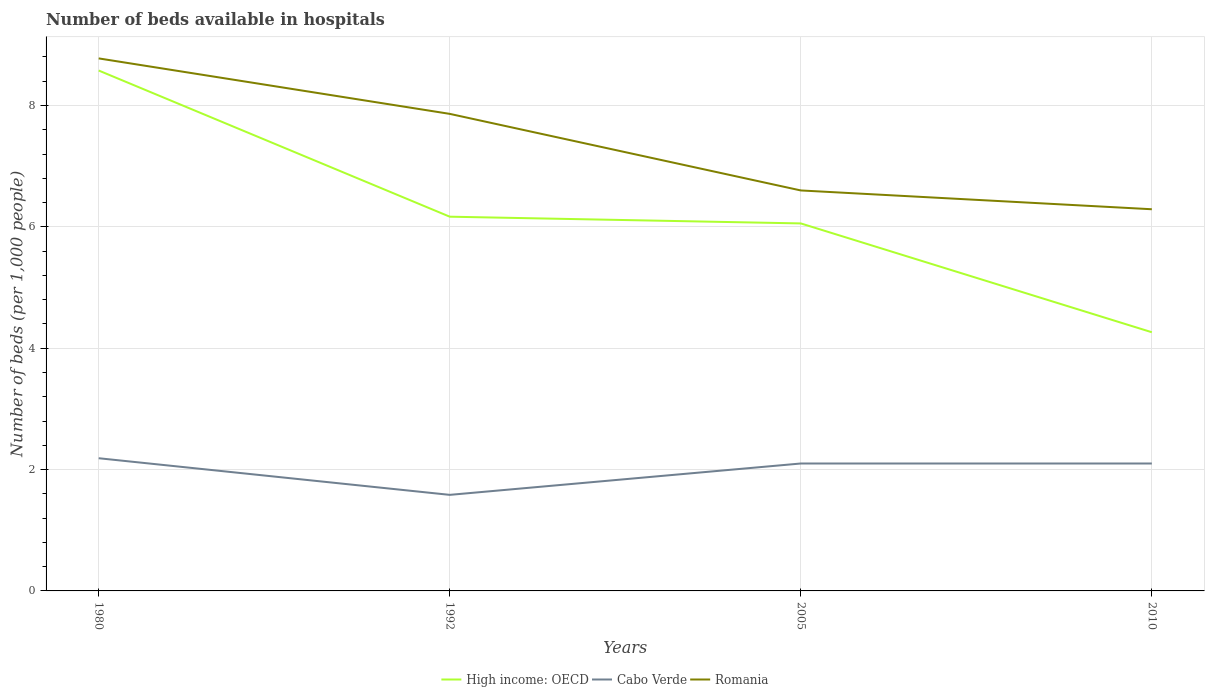How many different coloured lines are there?
Offer a very short reply. 3. Does the line corresponding to Romania intersect with the line corresponding to Cabo Verde?
Your answer should be compact. No. Across all years, what is the maximum number of beds in the hospiatls of in High income: OECD?
Ensure brevity in your answer.  4.26. What is the total number of beds in the hospiatls of in High income: OECD in the graph?
Your answer should be very brief. 1.79. What is the difference between the highest and the second highest number of beds in the hospiatls of in Romania?
Make the answer very short. 2.49. What is the difference between two consecutive major ticks on the Y-axis?
Give a very brief answer. 2. Are the values on the major ticks of Y-axis written in scientific E-notation?
Offer a very short reply. No. Where does the legend appear in the graph?
Ensure brevity in your answer.  Bottom center. How are the legend labels stacked?
Offer a terse response. Horizontal. What is the title of the graph?
Your answer should be very brief. Number of beds available in hospitals. Does "Ecuador" appear as one of the legend labels in the graph?
Provide a succinct answer. No. What is the label or title of the X-axis?
Offer a terse response. Years. What is the label or title of the Y-axis?
Offer a terse response. Number of beds (per 1,0 people). What is the Number of beds (per 1,000 people) in High income: OECD in 1980?
Provide a succinct answer. 8.58. What is the Number of beds (per 1,000 people) of Cabo Verde in 1980?
Keep it short and to the point. 2.19. What is the Number of beds (per 1,000 people) of Romania in 1980?
Keep it short and to the point. 8.78. What is the Number of beds (per 1,000 people) of High income: OECD in 1992?
Give a very brief answer. 6.17. What is the Number of beds (per 1,000 people) in Cabo Verde in 1992?
Provide a succinct answer. 1.58. What is the Number of beds (per 1,000 people) of Romania in 1992?
Ensure brevity in your answer.  7.86. What is the Number of beds (per 1,000 people) in High income: OECD in 2005?
Keep it short and to the point. 6.06. What is the Number of beds (per 1,000 people) in High income: OECD in 2010?
Make the answer very short. 4.26. What is the Number of beds (per 1,000 people) in Romania in 2010?
Offer a terse response. 6.29. Across all years, what is the maximum Number of beds (per 1,000 people) in High income: OECD?
Your answer should be very brief. 8.58. Across all years, what is the maximum Number of beds (per 1,000 people) in Cabo Verde?
Provide a short and direct response. 2.19. Across all years, what is the maximum Number of beds (per 1,000 people) of Romania?
Keep it short and to the point. 8.78. Across all years, what is the minimum Number of beds (per 1,000 people) in High income: OECD?
Give a very brief answer. 4.26. Across all years, what is the minimum Number of beds (per 1,000 people) in Cabo Verde?
Your response must be concise. 1.58. Across all years, what is the minimum Number of beds (per 1,000 people) of Romania?
Ensure brevity in your answer.  6.29. What is the total Number of beds (per 1,000 people) in High income: OECD in the graph?
Make the answer very short. 25.06. What is the total Number of beds (per 1,000 people) of Cabo Verde in the graph?
Provide a succinct answer. 7.97. What is the total Number of beds (per 1,000 people) in Romania in the graph?
Provide a short and direct response. 29.53. What is the difference between the Number of beds (per 1,000 people) in High income: OECD in 1980 and that in 1992?
Make the answer very short. 2.41. What is the difference between the Number of beds (per 1,000 people) in Cabo Verde in 1980 and that in 1992?
Give a very brief answer. 0.6. What is the difference between the Number of beds (per 1,000 people) in Romania in 1980 and that in 1992?
Your answer should be compact. 0.91. What is the difference between the Number of beds (per 1,000 people) in High income: OECD in 1980 and that in 2005?
Your answer should be compact. 2.52. What is the difference between the Number of beds (per 1,000 people) of Cabo Verde in 1980 and that in 2005?
Your answer should be very brief. 0.09. What is the difference between the Number of beds (per 1,000 people) of Romania in 1980 and that in 2005?
Make the answer very short. 2.18. What is the difference between the Number of beds (per 1,000 people) in High income: OECD in 1980 and that in 2010?
Keep it short and to the point. 4.31. What is the difference between the Number of beds (per 1,000 people) of Cabo Verde in 1980 and that in 2010?
Make the answer very short. 0.09. What is the difference between the Number of beds (per 1,000 people) in Romania in 1980 and that in 2010?
Make the answer very short. 2.49. What is the difference between the Number of beds (per 1,000 people) of High income: OECD in 1992 and that in 2005?
Your answer should be very brief. 0.11. What is the difference between the Number of beds (per 1,000 people) of Cabo Verde in 1992 and that in 2005?
Your answer should be very brief. -0.52. What is the difference between the Number of beds (per 1,000 people) in Romania in 1992 and that in 2005?
Give a very brief answer. 1.26. What is the difference between the Number of beds (per 1,000 people) of High income: OECD in 1992 and that in 2010?
Ensure brevity in your answer.  1.9. What is the difference between the Number of beds (per 1,000 people) of Cabo Verde in 1992 and that in 2010?
Offer a terse response. -0.52. What is the difference between the Number of beds (per 1,000 people) in Romania in 1992 and that in 2010?
Ensure brevity in your answer.  1.57. What is the difference between the Number of beds (per 1,000 people) of High income: OECD in 2005 and that in 2010?
Provide a succinct answer. 1.79. What is the difference between the Number of beds (per 1,000 people) in Romania in 2005 and that in 2010?
Ensure brevity in your answer.  0.31. What is the difference between the Number of beds (per 1,000 people) of High income: OECD in 1980 and the Number of beds (per 1,000 people) of Cabo Verde in 1992?
Offer a very short reply. 6.99. What is the difference between the Number of beds (per 1,000 people) of High income: OECD in 1980 and the Number of beds (per 1,000 people) of Romania in 1992?
Your answer should be very brief. 0.71. What is the difference between the Number of beds (per 1,000 people) of Cabo Verde in 1980 and the Number of beds (per 1,000 people) of Romania in 1992?
Make the answer very short. -5.68. What is the difference between the Number of beds (per 1,000 people) in High income: OECD in 1980 and the Number of beds (per 1,000 people) in Cabo Verde in 2005?
Offer a very short reply. 6.48. What is the difference between the Number of beds (per 1,000 people) in High income: OECD in 1980 and the Number of beds (per 1,000 people) in Romania in 2005?
Keep it short and to the point. 1.98. What is the difference between the Number of beds (per 1,000 people) in Cabo Verde in 1980 and the Number of beds (per 1,000 people) in Romania in 2005?
Your answer should be compact. -4.41. What is the difference between the Number of beds (per 1,000 people) of High income: OECD in 1980 and the Number of beds (per 1,000 people) of Cabo Verde in 2010?
Your answer should be compact. 6.48. What is the difference between the Number of beds (per 1,000 people) of High income: OECD in 1980 and the Number of beds (per 1,000 people) of Romania in 2010?
Provide a succinct answer. 2.29. What is the difference between the Number of beds (per 1,000 people) of Cabo Verde in 1980 and the Number of beds (per 1,000 people) of Romania in 2010?
Your answer should be compact. -4.1. What is the difference between the Number of beds (per 1,000 people) of High income: OECD in 1992 and the Number of beds (per 1,000 people) of Cabo Verde in 2005?
Provide a short and direct response. 4.07. What is the difference between the Number of beds (per 1,000 people) of High income: OECD in 1992 and the Number of beds (per 1,000 people) of Romania in 2005?
Provide a short and direct response. -0.43. What is the difference between the Number of beds (per 1,000 people) of Cabo Verde in 1992 and the Number of beds (per 1,000 people) of Romania in 2005?
Offer a terse response. -5.02. What is the difference between the Number of beds (per 1,000 people) in High income: OECD in 1992 and the Number of beds (per 1,000 people) in Cabo Verde in 2010?
Offer a very short reply. 4.07. What is the difference between the Number of beds (per 1,000 people) in High income: OECD in 1992 and the Number of beds (per 1,000 people) in Romania in 2010?
Your answer should be compact. -0.12. What is the difference between the Number of beds (per 1,000 people) of Cabo Verde in 1992 and the Number of beds (per 1,000 people) of Romania in 2010?
Your answer should be compact. -4.71. What is the difference between the Number of beds (per 1,000 people) of High income: OECD in 2005 and the Number of beds (per 1,000 people) of Cabo Verde in 2010?
Provide a succinct answer. 3.96. What is the difference between the Number of beds (per 1,000 people) of High income: OECD in 2005 and the Number of beds (per 1,000 people) of Romania in 2010?
Keep it short and to the point. -0.23. What is the difference between the Number of beds (per 1,000 people) in Cabo Verde in 2005 and the Number of beds (per 1,000 people) in Romania in 2010?
Offer a very short reply. -4.19. What is the average Number of beds (per 1,000 people) of High income: OECD per year?
Your answer should be very brief. 6.27. What is the average Number of beds (per 1,000 people) of Cabo Verde per year?
Your answer should be very brief. 1.99. What is the average Number of beds (per 1,000 people) of Romania per year?
Your answer should be very brief. 7.38. In the year 1980, what is the difference between the Number of beds (per 1,000 people) of High income: OECD and Number of beds (per 1,000 people) of Cabo Verde?
Your answer should be very brief. 6.39. In the year 1980, what is the difference between the Number of beds (per 1,000 people) in High income: OECD and Number of beds (per 1,000 people) in Romania?
Make the answer very short. -0.2. In the year 1980, what is the difference between the Number of beds (per 1,000 people) in Cabo Verde and Number of beds (per 1,000 people) in Romania?
Offer a terse response. -6.59. In the year 1992, what is the difference between the Number of beds (per 1,000 people) in High income: OECD and Number of beds (per 1,000 people) in Cabo Verde?
Keep it short and to the point. 4.58. In the year 1992, what is the difference between the Number of beds (per 1,000 people) of High income: OECD and Number of beds (per 1,000 people) of Romania?
Your answer should be very brief. -1.69. In the year 1992, what is the difference between the Number of beds (per 1,000 people) in Cabo Verde and Number of beds (per 1,000 people) in Romania?
Offer a terse response. -6.28. In the year 2005, what is the difference between the Number of beds (per 1,000 people) of High income: OECD and Number of beds (per 1,000 people) of Cabo Verde?
Ensure brevity in your answer.  3.96. In the year 2005, what is the difference between the Number of beds (per 1,000 people) of High income: OECD and Number of beds (per 1,000 people) of Romania?
Give a very brief answer. -0.54. In the year 2005, what is the difference between the Number of beds (per 1,000 people) of Cabo Verde and Number of beds (per 1,000 people) of Romania?
Make the answer very short. -4.5. In the year 2010, what is the difference between the Number of beds (per 1,000 people) in High income: OECD and Number of beds (per 1,000 people) in Cabo Verde?
Your answer should be compact. 2.16. In the year 2010, what is the difference between the Number of beds (per 1,000 people) of High income: OECD and Number of beds (per 1,000 people) of Romania?
Offer a very short reply. -2.03. In the year 2010, what is the difference between the Number of beds (per 1,000 people) in Cabo Verde and Number of beds (per 1,000 people) in Romania?
Offer a terse response. -4.19. What is the ratio of the Number of beds (per 1,000 people) of High income: OECD in 1980 to that in 1992?
Your response must be concise. 1.39. What is the ratio of the Number of beds (per 1,000 people) in Cabo Verde in 1980 to that in 1992?
Ensure brevity in your answer.  1.38. What is the ratio of the Number of beds (per 1,000 people) of Romania in 1980 to that in 1992?
Offer a very short reply. 1.12. What is the ratio of the Number of beds (per 1,000 people) in High income: OECD in 1980 to that in 2005?
Offer a terse response. 1.42. What is the ratio of the Number of beds (per 1,000 people) of Cabo Verde in 1980 to that in 2005?
Ensure brevity in your answer.  1.04. What is the ratio of the Number of beds (per 1,000 people) of Romania in 1980 to that in 2005?
Your response must be concise. 1.33. What is the ratio of the Number of beds (per 1,000 people) of High income: OECD in 1980 to that in 2010?
Your answer should be compact. 2.01. What is the ratio of the Number of beds (per 1,000 people) in Cabo Verde in 1980 to that in 2010?
Provide a succinct answer. 1.04. What is the ratio of the Number of beds (per 1,000 people) of Romania in 1980 to that in 2010?
Offer a terse response. 1.4. What is the ratio of the Number of beds (per 1,000 people) of High income: OECD in 1992 to that in 2005?
Give a very brief answer. 1.02. What is the ratio of the Number of beds (per 1,000 people) in Cabo Verde in 1992 to that in 2005?
Provide a succinct answer. 0.75. What is the ratio of the Number of beds (per 1,000 people) in Romania in 1992 to that in 2005?
Give a very brief answer. 1.19. What is the ratio of the Number of beds (per 1,000 people) of High income: OECD in 1992 to that in 2010?
Offer a terse response. 1.45. What is the ratio of the Number of beds (per 1,000 people) in Cabo Verde in 1992 to that in 2010?
Provide a short and direct response. 0.75. What is the ratio of the Number of beds (per 1,000 people) of Romania in 1992 to that in 2010?
Your answer should be very brief. 1.25. What is the ratio of the Number of beds (per 1,000 people) of High income: OECD in 2005 to that in 2010?
Your answer should be compact. 1.42. What is the ratio of the Number of beds (per 1,000 people) of Cabo Verde in 2005 to that in 2010?
Ensure brevity in your answer.  1. What is the ratio of the Number of beds (per 1,000 people) in Romania in 2005 to that in 2010?
Provide a succinct answer. 1.05. What is the difference between the highest and the second highest Number of beds (per 1,000 people) of High income: OECD?
Make the answer very short. 2.41. What is the difference between the highest and the second highest Number of beds (per 1,000 people) in Cabo Verde?
Ensure brevity in your answer.  0.09. What is the difference between the highest and the second highest Number of beds (per 1,000 people) in Romania?
Provide a succinct answer. 0.91. What is the difference between the highest and the lowest Number of beds (per 1,000 people) of High income: OECD?
Give a very brief answer. 4.31. What is the difference between the highest and the lowest Number of beds (per 1,000 people) in Cabo Verde?
Provide a short and direct response. 0.6. What is the difference between the highest and the lowest Number of beds (per 1,000 people) in Romania?
Your response must be concise. 2.49. 